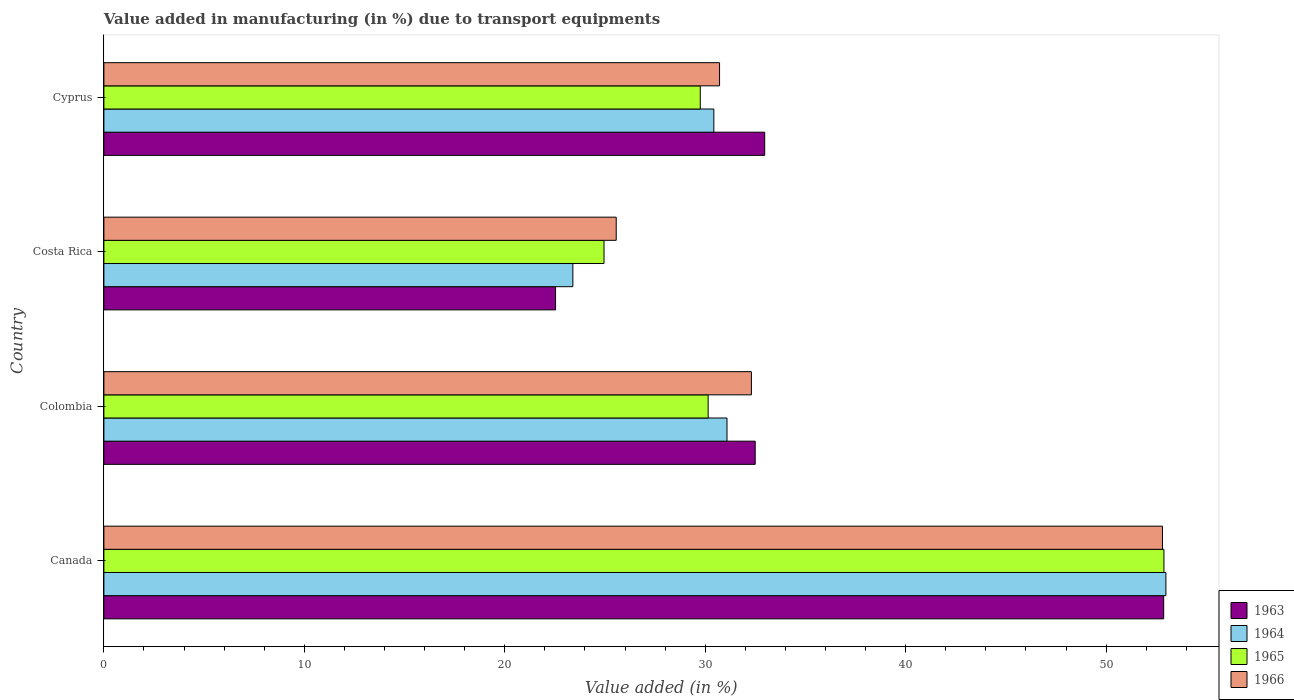Are the number of bars per tick equal to the number of legend labels?
Make the answer very short. Yes. Are the number of bars on each tick of the Y-axis equal?
Your answer should be very brief. Yes. How many bars are there on the 4th tick from the top?
Offer a terse response. 4. What is the label of the 4th group of bars from the top?
Keep it short and to the point. Canada. In how many cases, is the number of bars for a given country not equal to the number of legend labels?
Offer a terse response. 0. What is the percentage of value added in manufacturing due to transport equipments in 1963 in Canada?
Provide a succinct answer. 52.87. Across all countries, what is the maximum percentage of value added in manufacturing due to transport equipments in 1966?
Ensure brevity in your answer.  52.81. Across all countries, what is the minimum percentage of value added in manufacturing due to transport equipments in 1963?
Your answer should be compact. 22.53. In which country was the percentage of value added in manufacturing due to transport equipments in 1966 minimum?
Your response must be concise. Costa Rica. What is the total percentage of value added in manufacturing due to transport equipments in 1963 in the graph?
Your answer should be very brief. 140.87. What is the difference between the percentage of value added in manufacturing due to transport equipments in 1963 in Costa Rica and that in Cyprus?
Ensure brevity in your answer.  -10.43. What is the difference between the percentage of value added in manufacturing due to transport equipments in 1963 in Colombia and the percentage of value added in manufacturing due to transport equipments in 1966 in Costa Rica?
Your response must be concise. 6.93. What is the average percentage of value added in manufacturing due to transport equipments in 1963 per country?
Your answer should be very brief. 35.22. What is the difference between the percentage of value added in manufacturing due to transport equipments in 1966 and percentage of value added in manufacturing due to transport equipments in 1964 in Cyprus?
Offer a terse response. 0.29. In how many countries, is the percentage of value added in manufacturing due to transport equipments in 1966 greater than 12 %?
Your answer should be very brief. 4. What is the ratio of the percentage of value added in manufacturing due to transport equipments in 1966 in Canada to that in Cyprus?
Offer a terse response. 1.72. Is the percentage of value added in manufacturing due to transport equipments in 1963 in Canada less than that in Cyprus?
Your answer should be very brief. No. Is the difference between the percentage of value added in manufacturing due to transport equipments in 1966 in Colombia and Costa Rica greater than the difference between the percentage of value added in manufacturing due to transport equipments in 1964 in Colombia and Costa Rica?
Provide a succinct answer. No. What is the difference between the highest and the second highest percentage of value added in manufacturing due to transport equipments in 1963?
Your answer should be compact. 19.91. What is the difference between the highest and the lowest percentage of value added in manufacturing due to transport equipments in 1966?
Provide a short and direct response. 27.25. In how many countries, is the percentage of value added in manufacturing due to transport equipments in 1963 greater than the average percentage of value added in manufacturing due to transport equipments in 1963 taken over all countries?
Your response must be concise. 1. Is it the case that in every country, the sum of the percentage of value added in manufacturing due to transport equipments in 1963 and percentage of value added in manufacturing due to transport equipments in 1964 is greater than the sum of percentage of value added in manufacturing due to transport equipments in 1965 and percentage of value added in manufacturing due to transport equipments in 1966?
Make the answer very short. No. What does the 1st bar from the top in Canada represents?
Your answer should be very brief. 1966. What does the 4th bar from the bottom in Canada represents?
Offer a very short reply. 1966. Is it the case that in every country, the sum of the percentage of value added in manufacturing due to transport equipments in 1966 and percentage of value added in manufacturing due to transport equipments in 1963 is greater than the percentage of value added in manufacturing due to transport equipments in 1965?
Provide a succinct answer. Yes. What is the difference between two consecutive major ticks on the X-axis?
Make the answer very short. 10. Does the graph contain any zero values?
Provide a short and direct response. No. Does the graph contain grids?
Your response must be concise. No. Where does the legend appear in the graph?
Ensure brevity in your answer.  Bottom right. How many legend labels are there?
Make the answer very short. 4. What is the title of the graph?
Provide a short and direct response. Value added in manufacturing (in %) due to transport equipments. Does "1968" appear as one of the legend labels in the graph?
Your response must be concise. No. What is the label or title of the X-axis?
Make the answer very short. Value added (in %). What is the label or title of the Y-axis?
Make the answer very short. Country. What is the Value added (in %) of 1963 in Canada?
Make the answer very short. 52.87. What is the Value added (in %) in 1964 in Canada?
Make the answer very short. 52.98. What is the Value added (in %) in 1965 in Canada?
Make the answer very short. 52.89. What is the Value added (in %) of 1966 in Canada?
Offer a terse response. 52.81. What is the Value added (in %) of 1963 in Colombia?
Keep it short and to the point. 32.49. What is the Value added (in %) in 1964 in Colombia?
Offer a terse response. 31.09. What is the Value added (in %) in 1965 in Colombia?
Make the answer very short. 30.15. What is the Value added (in %) of 1966 in Colombia?
Your answer should be compact. 32.3. What is the Value added (in %) in 1963 in Costa Rica?
Offer a very short reply. 22.53. What is the Value added (in %) of 1964 in Costa Rica?
Your answer should be very brief. 23.4. What is the Value added (in %) of 1965 in Costa Rica?
Offer a very short reply. 24.95. What is the Value added (in %) in 1966 in Costa Rica?
Offer a very short reply. 25.56. What is the Value added (in %) of 1963 in Cyprus?
Offer a very short reply. 32.97. What is the Value added (in %) of 1964 in Cyprus?
Your answer should be very brief. 30.43. What is the Value added (in %) of 1965 in Cyprus?
Give a very brief answer. 29.75. What is the Value added (in %) of 1966 in Cyprus?
Offer a very short reply. 30.72. Across all countries, what is the maximum Value added (in %) in 1963?
Offer a terse response. 52.87. Across all countries, what is the maximum Value added (in %) in 1964?
Your response must be concise. 52.98. Across all countries, what is the maximum Value added (in %) in 1965?
Give a very brief answer. 52.89. Across all countries, what is the maximum Value added (in %) in 1966?
Provide a succinct answer. 52.81. Across all countries, what is the minimum Value added (in %) in 1963?
Your response must be concise. 22.53. Across all countries, what is the minimum Value added (in %) of 1964?
Your answer should be compact. 23.4. Across all countries, what is the minimum Value added (in %) of 1965?
Offer a terse response. 24.95. Across all countries, what is the minimum Value added (in %) in 1966?
Your answer should be compact. 25.56. What is the total Value added (in %) in 1963 in the graph?
Provide a short and direct response. 140.87. What is the total Value added (in %) of 1964 in the graph?
Offer a terse response. 137.89. What is the total Value added (in %) of 1965 in the graph?
Offer a very short reply. 137.73. What is the total Value added (in %) of 1966 in the graph?
Give a very brief answer. 141.39. What is the difference between the Value added (in %) in 1963 in Canada and that in Colombia?
Provide a succinct answer. 20.38. What is the difference between the Value added (in %) in 1964 in Canada and that in Colombia?
Your answer should be very brief. 21.9. What is the difference between the Value added (in %) of 1965 in Canada and that in Colombia?
Keep it short and to the point. 22.74. What is the difference between the Value added (in %) in 1966 in Canada and that in Colombia?
Provide a short and direct response. 20.51. What is the difference between the Value added (in %) of 1963 in Canada and that in Costa Rica?
Offer a terse response. 30.34. What is the difference between the Value added (in %) of 1964 in Canada and that in Costa Rica?
Your response must be concise. 29.59. What is the difference between the Value added (in %) of 1965 in Canada and that in Costa Rica?
Ensure brevity in your answer.  27.93. What is the difference between the Value added (in %) of 1966 in Canada and that in Costa Rica?
Make the answer very short. 27.25. What is the difference between the Value added (in %) in 1963 in Canada and that in Cyprus?
Make the answer very short. 19.91. What is the difference between the Value added (in %) of 1964 in Canada and that in Cyprus?
Your answer should be very brief. 22.55. What is the difference between the Value added (in %) in 1965 in Canada and that in Cyprus?
Provide a succinct answer. 23.13. What is the difference between the Value added (in %) in 1966 in Canada and that in Cyprus?
Provide a short and direct response. 22.1. What is the difference between the Value added (in %) of 1963 in Colombia and that in Costa Rica?
Give a very brief answer. 9.96. What is the difference between the Value added (in %) in 1964 in Colombia and that in Costa Rica?
Your answer should be very brief. 7.69. What is the difference between the Value added (in %) of 1965 in Colombia and that in Costa Rica?
Give a very brief answer. 5.2. What is the difference between the Value added (in %) of 1966 in Colombia and that in Costa Rica?
Give a very brief answer. 6.74. What is the difference between the Value added (in %) in 1963 in Colombia and that in Cyprus?
Your answer should be compact. -0.47. What is the difference between the Value added (in %) of 1964 in Colombia and that in Cyprus?
Ensure brevity in your answer.  0.66. What is the difference between the Value added (in %) of 1965 in Colombia and that in Cyprus?
Keep it short and to the point. 0.39. What is the difference between the Value added (in %) of 1966 in Colombia and that in Cyprus?
Offer a terse response. 1.59. What is the difference between the Value added (in %) of 1963 in Costa Rica and that in Cyprus?
Your answer should be very brief. -10.43. What is the difference between the Value added (in %) of 1964 in Costa Rica and that in Cyprus?
Provide a succinct answer. -7.03. What is the difference between the Value added (in %) in 1965 in Costa Rica and that in Cyprus?
Ensure brevity in your answer.  -4.8. What is the difference between the Value added (in %) in 1966 in Costa Rica and that in Cyprus?
Offer a terse response. -5.16. What is the difference between the Value added (in %) in 1963 in Canada and the Value added (in %) in 1964 in Colombia?
Offer a very short reply. 21.79. What is the difference between the Value added (in %) of 1963 in Canada and the Value added (in %) of 1965 in Colombia?
Your answer should be compact. 22.73. What is the difference between the Value added (in %) of 1963 in Canada and the Value added (in %) of 1966 in Colombia?
Offer a terse response. 20.57. What is the difference between the Value added (in %) of 1964 in Canada and the Value added (in %) of 1965 in Colombia?
Keep it short and to the point. 22.84. What is the difference between the Value added (in %) in 1964 in Canada and the Value added (in %) in 1966 in Colombia?
Ensure brevity in your answer.  20.68. What is the difference between the Value added (in %) in 1965 in Canada and the Value added (in %) in 1966 in Colombia?
Your response must be concise. 20.58. What is the difference between the Value added (in %) in 1963 in Canada and the Value added (in %) in 1964 in Costa Rica?
Your answer should be very brief. 29.48. What is the difference between the Value added (in %) of 1963 in Canada and the Value added (in %) of 1965 in Costa Rica?
Your answer should be compact. 27.92. What is the difference between the Value added (in %) in 1963 in Canada and the Value added (in %) in 1966 in Costa Rica?
Your answer should be very brief. 27.31. What is the difference between the Value added (in %) in 1964 in Canada and the Value added (in %) in 1965 in Costa Rica?
Keep it short and to the point. 28.03. What is the difference between the Value added (in %) in 1964 in Canada and the Value added (in %) in 1966 in Costa Rica?
Make the answer very short. 27.42. What is the difference between the Value added (in %) of 1965 in Canada and the Value added (in %) of 1966 in Costa Rica?
Provide a short and direct response. 27.33. What is the difference between the Value added (in %) in 1963 in Canada and the Value added (in %) in 1964 in Cyprus?
Give a very brief answer. 22.44. What is the difference between the Value added (in %) in 1963 in Canada and the Value added (in %) in 1965 in Cyprus?
Offer a very short reply. 23.12. What is the difference between the Value added (in %) of 1963 in Canada and the Value added (in %) of 1966 in Cyprus?
Your response must be concise. 22.16. What is the difference between the Value added (in %) in 1964 in Canada and the Value added (in %) in 1965 in Cyprus?
Ensure brevity in your answer.  23.23. What is the difference between the Value added (in %) of 1964 in Canada and the Value added (in %) of 1966 in Cyprus?
Your answer should be compact. 22.27. What is the difference between the Value added (in %) of 1965 in Canada and the Value added (in %) of 1966 in Cyprus?
Make the answer very short. 22.17. What is the difference between the Value added (in %) of 1963 in Colombia and the Value added (in %) of 1964 in Costa Rica?
Your answer should be compact. 9.1. What is the difference between the Value added (in %) in 1963 in Colombia and the Value added (in %) in 1965 in Costa Rica?
Provide a short and direct response. 7.54. What is the difference between the Value added (in %) of 1963 in Colombia and the Value added (in %) of 1966 in Costa Rica?
Make the answer very short. 6.93. What is the difference between the Value added (in %) in 1964 in Colombia and the Value added (in %) in 1965 in Costa Rica?
Provide a short and direct response. 6.14. What is the difference between the Value added (in %) in 1964 in Colombia and the Value added (in %) in 1966 in Costa Rica?
Your answer should be very brief. 5.53. What is the difference between the Value added (in %) of 1965 in Colombia and the Value added (in %) of 1966 in Costa Rica?
Ensure brevity in your answer.  4.59. What is the difference between the Value added (in %) of 1963 in Colombia and the Value added (in %) of 1964 in Cyprus?
Offer a terse response. 2.06. What is the difference between the Value added (in %) in 1963 in Colombia and the Value added (in %) in 1965 in Cyprus?
Your answer should be compact. 2.74. What is the difference between the Value added (in %) in 1963 in Colombia and the Value added (in %) in 1966 in Cyprus?
Keep it short and to the point. 1.78. What is the difference between the Value added (in %) in 1964 in Colombia and the Value added (in %) in 1965 in Cyprus?
Ensure brevity in your answer.  1.33. What is the difference between the Value added (in %) of 1964 in Colombia and the Value added (in %) of 1966 in Cyprus?
Ensure brevity in your answer.  0.37. What is the difference between the Value added (in %) of 1965 in Colombia and the Value added (in %) of 1966 in Cyprus?
Your answer should be compact. -0.57. What is the difference between the Value added (in %) in 1963 in Costa Rica and the Value added (in %) in 1964 in Cyprus?
Your response must be concise. -7.9. What is the difference between the Value added (in %) in 1963 in Costa Rica and the Value added (in %) in 1965 in Cyprus?
Offer a very short reply. -7.22. What is the difference between the Value added (in %) in 1963 in Costa Rica and the Value added (in %) in 1966 in Cyprus?
Ensure brevity in your answer.  -8.18. What is the difference between the Value added (in %) in 1964 in Costa Rica and the Value added (in %) in 1965 in Cyprus?
Ensure brevity in your answer.  -6.36. What is the difference between the Value added (in %) in 1964 in Costa Rica and the Value added (in %) in 1966 in Cyprus?
Ensure brevity in your answer.  -7.32. What is the difference between the Value added (in %) of 1965 in Costa Rica and the Value added (in %) of 1966 in Cyprus?
Provide a succinct answer. -5.77. What is the average Value added (in %) in 1963 per country?
Give a very brief answer. 35.22. What is the average Value added (in %) of 1964 per country?
Keep it short and to the point. 34.47. What is the average Value added (in %) of 1965 per country?
Offer a terse response. 34.43. What is the average Value added (in %) in 1966 per country?
Provide a succinct answer. 35.35. What is the difference between the Value added (in %) of 1963 and Value added (in %) of 1964 in Canada?
Ensure brevity in your answer.  -0.11. What is the difference between the Value added (in %) of 1963 and Value added (in %) of 1965 in Canada?
Keep it short and to the point. -0.01. What is the difference between the Value added (in %) of 1963 and Value added (in %) of 1966 in Canada?
Give a very brief answer. 0.06. What is the difference between the Value added (in %) of 1964 and Value added (in %) of 1965 in Canada?
Your response must be concise. 0.1. What is the difference between the Value added (in %) of 1964 and Value added (in %) of 1966 in Canada?
Offer a very short reply. 0.17. What is the difference between the Value added (in %) of 1965 and Value added (in %) of 1966 in Canada?
Ensure brevity in your answer.  0.07. What is the difference between the Value added (in %) in 1963 and Value added (in %) in 1964 in Colombia?
Keep it short and to the point. 1.41. What is the difference between the Value added (in %) in 1963 and Value added (in %) in 1965 in Colombia?
Make the answer very short. 2.35. What is the difference between the Value added (in %) in 1963 and Value added (in %) in 1966 in Colombia?
Ensure brevity in your answer.  0.19. What is the difference between the Value added (in %) in 1964 and Value added (in %) in 1965 in Colombia?
Keep it short and to the point. 0.94. What is the difference between the Value added (in %) in 1964 and Value added (in %) in 1966 in Colombia?
Your answer should be very brief. -1.22. What is the difference between the Value added (in %) in 1965 and Value added (in %) in 1966 in Colombia?
Make the answer very short. -2.16. What is the difference between the Value added (in %) of 1963 and Value added (in %) of 1964 in Costa Rica?
Provide a short and direct response. -0.86. What is the difference between the Value added (in %) of 1963 and Value added (in %) of 1965 in Costa Rica?
Offer a very short reply. -2.42. What is the difference between the Value added (in %) in 1963 and Value added (in %) in 1966 in Costa Rica?
Ensure brevity in your answer.  -3.03. What is the difference between the Value added (in %) in 1964 and Value added (in %) in 1965 in Costa Rica?
Make the answer very short. -1.55. What is the difference between the Value added (in %) of 1964 and Value added (in %) of 1966 in Costa Rica?
Ensure brevity in your answer.  -2.16. What is the difference between the Value added (in %) in 1965 and Value added (in %) in 1966 in Costa Rica?
Provide a short and direct response. -0.61. What is the difference between the Value added (in %) in 1963 and Value added (in %) in 1964 in Cyprus?
Make the answer very short. 2.54. What is the difference between the Value added (in %) in 1963 and Value added (in %) in 1965 in Cyprus?
Give a very brief answer. 3.21. What is the difference between the Value added (in %) of 1963 and Value added (in %) of 1966 in Cyprus?
Provide a succinct answer. 2.25. What is the difference between the Value added (in %) of 1964 and Value added (in %) of 1965 in Cyprus?
Your answer should be very brief. 0.68. What is the difference between the Value added (in %) of 1964 and Value added (in %) of 1966 in Cyprus?
Your answer should be very brief. -0.29. What is the difference between the Value added (in %) in 1965 and Value added (in %) in 1966 in Cyprus?
Offer a very short reply. -0.96. What is the ratio of the Value added (in %) in 1963 in Canada to that in Colombia?
Offer a very short reply. 1.63. What is the ratio of the Value added (in %) in 1964 in Canada to that in Colombia?
Your answer should be compact. 1.7. What is the ratio of the Value added (in %) of 1965 in Canada to that in Colombia?
Your answer should be compact. 1.75. What is the ratio of the Value added (in %) in 1966 in Canada to that in Colombia?
Your response must be concise. 1.63. What is the ratio of the Value added (in %) of 1963 in Canada to that in Costa Rica?
Make the answer very short. 2.35. What is the ratio of the Value added (in %) in 1964 in Canada to that in Costa Rica?
Keep it short and to the point. 2.26. What is the ratio of the Value added (in %) of 1965 in Canada to that in Costa Rica?
Offer a terse response. 2.12. What is the ratio of the Value added (in %) of 1966 in Canada to that in Costa Rica?
Give a very brief answer. 2.07. What is the ratio of the Value added (in %) in 1963 in Canada to that in Cyprus?
Give a very brief answer. 1.6. What is the ratio of the Value added (in %) in 1964 in Canada to that in Cyprus?
Your answer should be very brief. 1.74. What is the ratio of the Value added (in %) of 1965 in Canada to that in Cyprus?
Make the answer very short. 1.78. What is the ratio of the Value added (in %) of 1966 in Canada to that in Cyprus?
Keep it short and to the point. 1.72. What is the ratio of the Value added (in %) of 1963 in Colombia to that in Costa Rica?
Keep it short and to the point. 1.44. What is the ratio of the Value added (in %) in 1964 in Colombia to that in Costa Rica?
Give a very brief answer. 1.33. What is the ratio of the Value added (in %) in 1965 in Colombia to that in Costa Rica?
Your answer should be compact. 1.21. What is the ratio of the Value added (in %) in 1966 in Colombia to that in Costa Rica?
Ensure brevity in your answer.  1.26. What is the ratio of the Value added (in %) in 1963 in Colombia to that in Cyprus?
Provide a short and direct response. 0.99. What is the ratio of the Value added (in %) in 1964 in Colombia to that in Cyprus?
Offer a very short reply. 1.02. What is the ratio of the Value added (in %) in 1965 in Colombia to that in Cyprus?
Give a very brief answer. 1.01. What is the ratio of the Value added (in %) of 1966 in Colombia to that in Cyprus?
Provide a short and direct response. 1.05. What is the ratio of the Value added (in %) in 1963 in Costa Rica to that in Cyprus?
Offer a very short reply. 0.68. What is the ratio of the Value added (in %) of 1964 in Costa Rica to that in Cyprus?
Your answer should be very brief. 0.77. What is the ratio of the Value added (in %) of 1965 in Costa Rica to that in Cyprus?
Offer a very short reply. 0.84. What is the ratio of the Value added (in %) in 1966 in Costa Rica to that in Cyprus?
Keep it short and to the point. 0.83. What is the difference between the highest and the second highest Value added (in %) in 1963?
Make the answer very short. 19.91. What is the difference between the highest and the second highest Value added (in %) in 1964?
Ensure brevity in your answer.  21.9. What is the difference between the highest and the second highest Value added (in %) in 1965?
Provide a succinct answer. 22.74. What is the difference between the highest and the second highest Value added (in %) in 1966?
Give a very brief answer. 20.51. What is the difference between the highest and the lowest Value added (in %) in 1963?
Your answer should be very brief. 30.34. What is the difference between the highest and the lowest Value added (in %) in 1964?
Provide a succinct answer. 29.59. What is the difference between the highest and the lowest Value added (in %) in 1965?
Offer a terse response. 27.93. What is the difference between the highest and the lowest Value added (in %) in 1966?
Your answer should be compact. 27.25. 